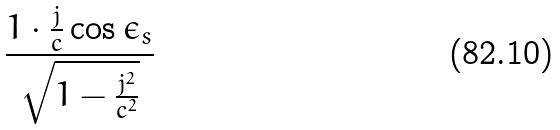Convert formula to latex. <formula><loc_0><loc_0><loc_500><loc_500>\frac { 1 \cdot \frac { j } { c } \cos \epsilon _ { s } } { \sqrt { 1 - \frac { j ^ { 2 } } { c ^ { 2 } } } }</formula> 